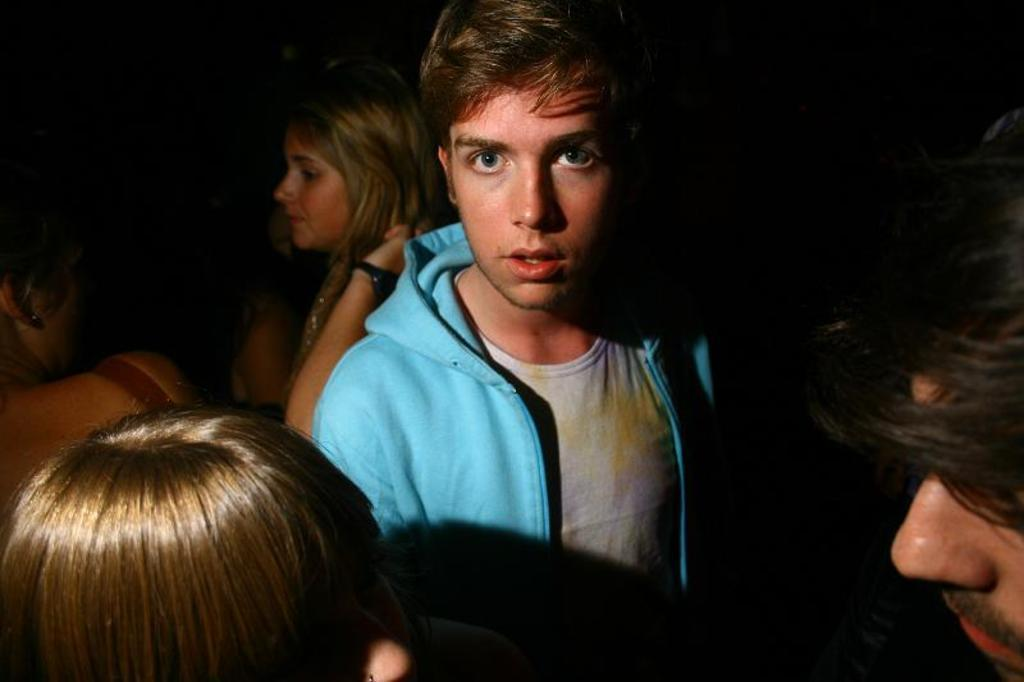How many individuals are present in the image? There is a group of people in the image, but the exact number cannot be determined without more information. Can you describe the group of people in the image? Unfortunately, the provided facts do not give any details about the group of people, such as their age, gender, or clothing. What might the group of people be doing in the image? Without more information, it is impossible to determine what the group of people is doing in the image. What type of grape is being used to make a statement in the image? There is no grape present in the image, nor is there any indication of a statement being made. 